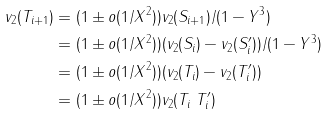Convert formula to latex. <formula><loc_0><loc_0><loc_500><loc_500>v _ { 2 } ( T _ { i + 1 } ) & = ( 1 \pm o ( 1 / X ^ { 2 } ) ) v _ { 2 } ( S _ { i + 1 } ) / ( 1 - Y ^ { 3 } ) \\ & = ( 1 \pm o ( 1 / X ^ { 2 } ) ) ( v _ { 2 } ( S _ { i } ) - v _ { 2 } ( S ^ { \prime } _ { i } ) ) / ( 1 - Y ^ { 3 } ) \\ & = ( 1 \pm o ( 1 / X ^ { 2 } ) ) ( v _ { 2 } ( T _ { i } ) - v _ { 2 } ( T ^ { \prime } _ { i } ) ) \\ & = ( 1 \pm o ( 1 / X ^ { 2 } ) ) v _ { 2 } ( T _ { i } \ T ^ { \prime } _ { i } )</formula> 